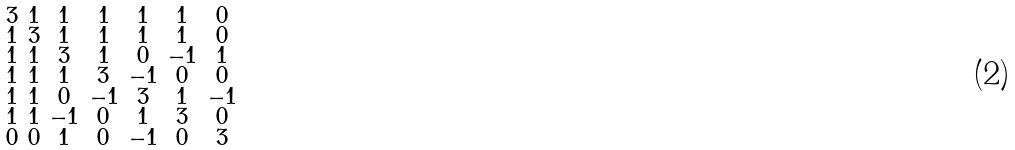Convert formula to latex. <formula><loc_0><loc_0><loc_500><loc_500>\begin{smallmatrix} 3 & 1 & 1 & 1 & 1 & 1 & 0 \\ 1 & 3 & 1 & 1 & 1 & 1 & 0 \\ 1 & 1 & 3 & 1 & 0 & - 1 & 1 \\ 1 & 1 & 1 & 3 & - 1 & 0 & 0 \\ 1 & 1 & 0 & - 1 & 3 & 1 & - 1 \\ 1 & 1 & - 1 & 0 & 1 & 3 & 0 \\ 0 & 0 & 1 & 0 & - 1 & 0 & 3 \end{smallmatrix}</formula> 